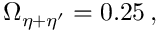Convert formula to latex. <formula><loc_0><loc_0><loc_500><loc_500>\Omega _ { \eta + \eta ^ { \prime } } = 0 . 2 5 \, ,</formula> 